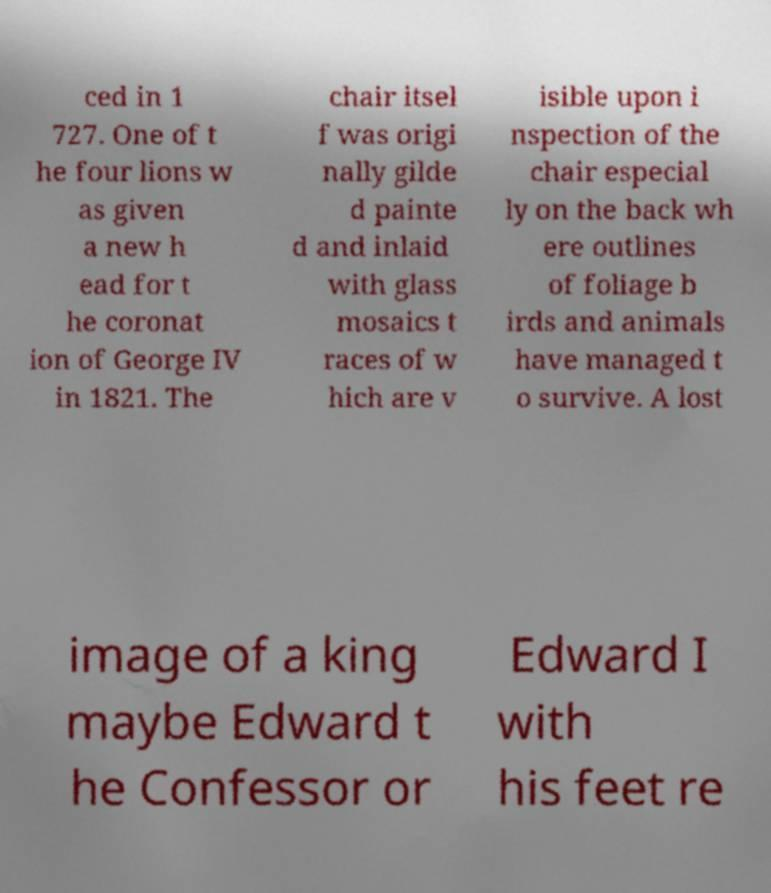I need the written content from this picture converted into text. Can you do that? ced in 1 727. One of t he four lions w as given a new h ead for t he coronat ion of George IV in 1821. The chair itsel f was origi nally gilde d painte d and inlaid with glass mosaics t races of w hich are v isible upon i nspection of the chair especial ly on the back wh ere outlines of foliage b irds and animals have managed t o survive. A lost image of a king maybe Edward t he Confessor or Edward I with his feet re 